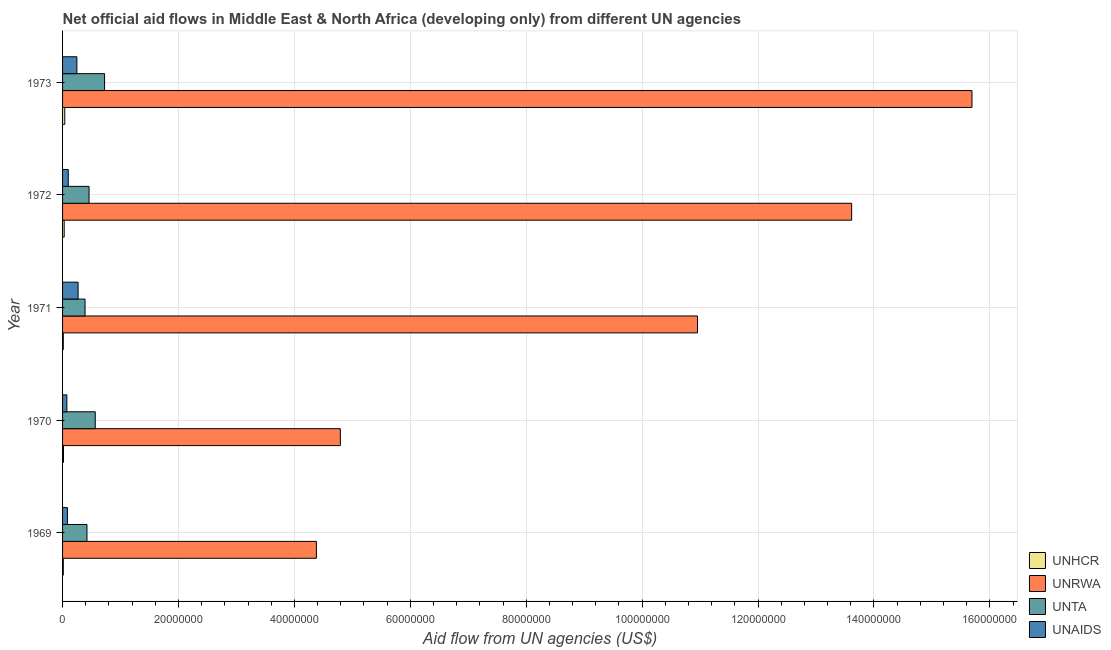How many different coloured bars are there?
Provide a succinct answer. 4. How many groups of bars are there?
Make the answer very short. 5. Are the number of bars per tick equal to the number of legend labels?
Your answer should be very brief. Yes. Are the number of bars on each tick of the Y-axis equal?
Provide a short and direct response. Yes. What is the label of the 2nd group of bars from the top?
Make the answer very short. 1972. What is the amount of aid given by unrwa in 1971?
Keep it short and to the point. 1.10e+08. Across all years, what is the maximum amount of aid given by unhcr?
Offer a terse response. 3.80e+05. Across all years, what is the minimum amount of aid given by unta?
Offer a very short reply. 3.88e+06. In which year was the amount of aid given by unaids maximum?
Ensure brevity in your answer.  1971. In which year was the amount of aid given by unaids minimum?
Give a very brief answer. 1970. What is the total amount of aid given by unrwa in the graph?
Provide a short and direct response. 4.94e+08. What is the difference between the amount of aid given by unta in 1969 and that in 1972?
Offer a terse response. -3.60e+05. What is the difference between the amount of aid given by unta in 1970 and the amount of aid given by unhcr in 1971?
Give a very brief answer. 5.51e+06. What is the average amount of aid given by unaids per year?
Offer a terse response. 1.54e+06. In the year 1973, what is the difference between the amount of aid given by unta and amount of aid given by unaids?
Provide a succinct answer. 4.78e+06. What is the ratio of the amount of aid given by unta in 1969 to that in 1971?
Provide a succinct answer. 1.08. Is the amount of aid given by unta in 1969 less than that in 1971?
Your answer should be very brief. No. Is the difference between the amount of aid given by unaids in 1972 and 1973 greater than the difference between the amount of aid given by unhcr in 1972 and 1973?
Offer a very short reply. No. What is the difference between the highest and the lowest amount of aid given by unaids?
Your response must be concise. 1.94e+06. In how many years, is the amount of aid given by unrwa greater than the average amount of aid given by unrwa taken over all years?
Keep it short and to the point. 3. Is the sum of the amount of aid given by unaids in 1970 and 1973 greater than the maximum amount of aid given by unhcr across all years?
Your response must be concise. Yes. Is it the case that in every year, the sum of the amount of aid given by unta and amount of aid given by unhcr is greater than the sum of amount of aid given by unaids and amount of aid given by unrwa?
Offer a terse response. Yes. What does the 2nd bar from the top in 1972 represents?
Provide a short and direct response. UNTA. What does the 4th bar from the bottom in 1973 represents?
Provide a short and direct response. UNAIDS. Is it the case that in every year, the sum of the amount of aid given by unhcr and amount of aid given by unrwa is greater than the amount of aid given by unta?
Provide a succinct answer. Yes. Are all the bars in the graph horizontal?
Make the answer very short. Yes. What is the difference between two consecutive major ticks on the X-axis?
Your answer should be very brief. 2.00e+07. Does the graph contain any zero values?
Offer a terse response. No. Does the graph contain grids?
Offer a terse response. Yes. How many legend labels are there?
Your answer should be compact. 4. What is the title of the graph?
Give a very brief answer. Net official aid flows in Middle East & North Africa (developing only) from different UN agencies. What is the label or title of the X-axis?
Ensure brevity in your answer.  Aid flow from UN agencies (US$). What is the Aid flow from UN agencies (US$) of UNRWA in 1969?
Your response must be concise. 4.38e+07. What is the Aid flow from UN agencies (US$) of UNTA in 1969?
Provide a succinct answer. 4.21e+06. What is the Aid flow from UN agencies (US$) of UNAIDS in 1969?
Provide a succinct answer. 8.40e+05. What is the Aid flow from UN agencies (US$) in UNRWA in 1970?
Provide a succinct answer. 4.79e+07. What is the Aid flow from UN agencies (US$) of UNTA in 1970?
Offer a very short reply. 5.64e+06. What is the Aid flow from UN agencies (US$) of UNAIDS in 1970?
Give a very brief answer. 7.40e+05. What is the Aid flow from UN agencies (US$) of UNHCR in 1971?
Your answer should be very brief. 1.30e+05. What is the Aid flow from UN agencies (US$) in UNRWA in 1971?
Make the answer very short. 1.10e+08. What is the Aid flow from UN agencies (US$) in UNTA in 1971?
Give a very brief answer. 3.88e+06. What is the Aid flow from UN agencies (US$) of UNAIDS in 1971?
Your answer should be compact. 2.68e+06. What is the Aid flow from UN agencies (US$) in UNRWA in 1972?
Your response must be concise. 1.36e+08. What is the Aid flow from UN agencies (US$) in UNTA in 1972?
Offer a very short reply. 4.57e+06. What is the Aid flow from UN agencies (US$) of UNAIDS in 1972?
Your answer should be very brief. 9.80e+05. What is the Aid flow from UN agencies (US$) in UNHCR in 1973?
Make the answer very short. 3.80e+05. What is the Aid flow from UN agencies (US$) in UNRWA in 1973?
Keep it short and to the point. 1.57e+08. What is the Aid flow from UN agencies (US$) of UNTA in 1973?
Ensure brevity in your answer.  7.25e+06. What is the Aid flow from UN agencies (US$) in UNAIDS in 1973?
Offer a very short reply. 2.47e+06. Across all years, what is the maximum Aid flow from UN agencies (US$) in UNHCR?
Your answer should be compact. 3.80e+05. Across all years, what is the maximum Aid flow from UN agencies (US$) of UNRWA?
Your answer should be very brief. 1.57e+08. Across all years, what is the maximum Aid flow from UN agencies (US$) in UNTA?
Ensure brevity in your answer.  7.25e+06. Across all years, what is the maximum Aid flow from UN agencies (US$) of UNAIDS?
Provide a succinct answer. 2.68e+06. Across all years, what is the minimum Aid flow from UN agencies (US$) of UNHCR?
Make the answer very short. 1.30e+05. Across all years, what is the minimum Aid flow from UN agencies (US$) in UNRWA?
Provide a short and direct response. 4.38e+07. Across all years, what is the minimum Aid flow from UN agencies (US$) of UNTA?
Make the answer very short. 3.88e+06. Across all years, what is the minimum Aid flow from UN agencies (US$) in UNAIDS?
Your answer should be compact. 7.40e+05. What is the total Aid flow from UN agencies (US$) of UNHCR in the graph?
Provide a succinct answer. 1.08e+06. What is the total Aid flow from UN agencies (US$) in UNRWA in the graph?
Keep it short and to the point. 4.94e+08. What is the total Aid flow from UN agencies (US$) of UNTA in the graph?
Offer a very short reply. 2.56e+07. What is the total Aid flow from UN agencies (US$) of UNAIDS in the graph?
Your response must be concise. 7.71e+06. What is the difference between the Aid flow from UN agencies (US$) in UNRWA in 1969 and that in 1970?
Your answer should be very brief. -4.13e+06. What is the difference between the Aid flow from UN agencies (US$) of UNTA in 1969 and that in 1970?
Your answer should be compact. -1.43e+06. What is the difference between the Aid flow from UN agencies (US$) of UNAIDS in 1969 and that in 1970?
Keep it short and to the point. 1.00e+05. What is the difference between the Aid flow from UN agencies (US$) in UNRWA in 1969 and that in 1971?
Your answer should be very brief. -6.58e+07. What is the difference between the Aid flow from UN agencies (US$) of UNAIDS in 1969 and that in 1971?
Ensure brevity in your answer.  -1.84e+06. What is the difference between the Aid flow from UN agencies (US$) of UNRWA in 1969 and that in 1972?
Your answer should be very brief. -9.24e+07. What is the difference between the Aid flow from UN agencies (US$) in UNTA in 1969 and that in 1972?
Offer a very short reply. -3.60e+05. What is the difference between the Aid flow from UN agencies (US$) in UNRWA in 1969 and that in 1973?
Offer a very short reply. -1.13e+08. What is the difference between the Aid flow from UN agencies (US$) in UNTA in 1969 and that in 1973?
Ensure brevity in your answer.  -3.04e+06. What is the difference between the Aid flow from UN agencies (US$) of UNAIDS in 1969 and that in 1973?
Give a very brief answer. -1.63e+06. What is the difference between the Aid flow from UN agencies (US$) in UNRWA in 1970 and that in 1971?
Offer a terse response. -6.16e+07. What is the difference between the Aid flow from UN agencies (US$) of UNTA in 1970 and that in 1971?
Offer a very short reply. 1.76e+06. What is the difference between the Aid flow from UN agencies (US$) of UNAIDS in 1970 and that in 1971?
Your answer should be compact. -1.94e+06. What is the difference between the Aid flow from UN agencies (US$) in UNRWA in 1970 and that in 1972?
Provide a succinct answer. -8.82e+07. What is the difference between the Aid flow from UN agencies (US$) of UNTA in 1970 and that in 1972?
Your answer should be compact. 1.07e+06. What is the difference between the Aid flow from UN agencies (US$) of UNHCR in 1970 and that in 1973?
Make the answer very short. -2.20e+05. What is the difference between the Aid flow from UN agencies (US$) in UNRWA in 1970 and that in 1973?
Provide a short and direct response. -1.09e+08. What is the difference between the Aid flow from UN agencies (US$) in UNTA in 1970 and that in 1973?
Your response must be concise. -1.61e+06. What is the difference between the Aid flow from UN agencies (US$) of UNAIDS in 1970 and that in 1973?
Make the answer very short. -1.73e+06. What is the difference between the Aid flow from UN agencies (US$) in UNHCR in 1971 and that in 1972?
Your answer should be very brief. -1.50e+05. What is the difference between the Aid flow from UN agencies (US$) of UNRWA in 1971 and that in 1972?
Offer a terse response. -2.66e+07. What is the difference between the Aid flow from UN agencies (US$) in UNTA in 1971 and that in 1972?
Ensure brevity in your answer.  -6.90e+05. What is the difference between the Aid flow from UN agencies (US$) in UNAIDS in 1971 and that in 1972?
Your answer should be compact. 1.70e+06. What is the difference between the Aid flow from UN agencies (US$) in UNRWA in 1971 and that in 1973?
Keep it short and to the point. -4.74e+07. What is the difference between the Aid flow from UN agencies (US$) in UNTA in 1971 and that in 1973?
Provide a short and direct response. -3.37e+06. What is the difference between the Aid flow from UN agencies (US$) of UNRWA in 1972 and that in 1973?
Offer a very short reply. -2.08e+07. What is the difference between the Aid flow from UN agencies (US$) in UNTA in 1972 and that in 1973?
Offer a terse response. -2.68e+06. What is the difference between the Aid flow from UN agencies (US$) of UNAIDS in 1972 and that in 1973?
Ensure brevity in your answer.  -1.49e+06. What is the difference between the Aid flow from UN agencies (US$) in UNHCR in 1969 and the Aid flow from UN agencies (US$) in UNRWA in 1970?
Make the answer very short. -4.78e+07. What is the difference between the Aid flow from UN agencies (US$) in UNHCR in 1969 and the Aid flow from UN agencies (US$) in UNTA in 1970?
Your answer should be very brief. -5.51e+06. What is the difference between the Aid flow from UN agencies (US$) in UNHCR in 1969 and the Aid flow from UN agencies (US$) in UNAIDS in 1970?
Your answer should be very brief. -6.10e+05. What is the difference between the Aid flow from UN agencies (US$) of UNRWA in 1969 and the Aid flow from UN agencies (US$) of UNTA in 1970?
Keep it short and to the point. 3.82e+07. What is the difference between the Aid flow from UN agencies (US$) of UNRWA in 1969 and the Aid flow from UN agencies (US$) of UNAIDS in 1970?
Make the answer very short. 4.31e+07. What is the difference between the Aid flow from UN agencies (US$) of UNTA in 1969 and the Aid flow from UN agencies (US$) of UNAIDS in 1970?
Make the answer very short. 3.47e+06. What is the difference between the Aid flow from UN agencies (US$) in UNHCR in 1969 and the Aid flow from UN agencies (US$) in UNRWA in 1971?
Provide a short and direct response. -1.09e+08. What is the difference between the Aid flow from UN agencies (US$) in UNHCR in 1969 and the Aid flow from UN agencies (US$) in UNTA in 1971?
Provide a short and direct response. -3.75e+06. What is the difference between the Aid flow from UN agencies (US$) in UNHCR in 1969 and the Aid flow from UN agencies (US$) in UNAIDS in 1971?
Ensure brevity in your answer.  -2.55e+06. What is the difference between the Aid flow from UN agencies (US$) in UNRWA in 1969 and the Aid flow from UN agencies (US$) in UNTA in 1971?
Offer a very short reply. 3.99e+07. What is the difference between the Aid flow from UN agencies (US$) of UNRWA in 1969 and the Aid flow from UN agencies (US$) of UNAIDS in 1971?
Provide a succinct answer. 4.11e+07. What is the difference between the Aid flow from UN agencies (US$) of UNTA in 1969 and the Aid flow from UN agencies (US$) of UNAIDS in 1971?
Your answer should be very brief. 1.53e+06. What is the difference between the Aid flow from UN agencies (US$) in UNHCR in 1969 and the Aid flow from UN agencies (US$) in UNRWA in 1972?
Offer a terse response. -1.36e+08. What is the difference between the Aid flow from UN agencies (US$) in UNHCR in 1969 and the Aid flow from UN agencies (US$) in UNTA in 1972?
Provide a succinct answer. -4.44e+06. What is the difference between the Aid flow from UN agencies (US$) in UNHCR in 1969 and the Aid flow from UN agencies (US$) in UNAIDS in 1972?
Keep it short and to the point. -8.50e+05. What is the difference between the Aid flow from UN agencies (US$) in UNRWA in 1969 and the Aid flow from UN agencies (US$) in UNTA in 1972?
Make the answer very short. 3.92e+07. What is the difference between the Aid flow from UN agencies (US$) in UNRWA in 1969 and the Aid flow from UN agencies (US$) in UNAIDS in 1972?
Make the answer very short. 4.28e+07. What is the difference between the Aid flow from UN agencies (US$) of UNTA in 1969 and the Aid flow from UN agencies (US$) of UNAIDS in 1972?
Make the answer very short. 3.23e+06. What is the difference between the Aid flow from UN agencies (US$) of UNHCR in 1969 and the Aid flow from UN agencies (US$) of UNRWA in 1973?
Your answer should be very brief. -1.57e+08. What is the difference between the Aid flow from UN agencies (US$) in UNHCR in 1969 and the Aid flow from UN agencies (US$) in UNTA in 1973?
Your response must be concise. -7.12e+06. What is the difference between the Aid flow from UN agencies (US$) in UNHCR in 1969 and the Aid flow from UN agencies (US$) in UNAIDS in 1973?
Provide a short and direct response. -2.34e+06. What is the difference between the Aid flow from UN agencies (US$) in UNRWA in 1969 and the Aid flow from UN agencies (US$) in UNTA in 1973?
Give a very brief answer. 3.66e+07. What is the difference between the Aid flow from UN agencies (US$) in UNRWA in 1969 and the Aid flow from UN agencies (US$) in UNAIDS in 1973?
Keep it short and to the point. 4.13e+07. What is the difference between the Aid flow from UN agencies (US$) in UNTA in 1969 and the Aid flow from UN agencies (US$) in UNAIDS in 1973?
Make the answer very short. 1.74e+06. What is the difference between the Aid flow from UN agencies (US$) of UNHCR in 1970 and the Aid flow from UN agencies (US$) of UNRWA in 1971?
Give a very brief answer. -1.09e+08. What is the difference between the Aid flow from UN agencies (US$) in UNHCR in 1970 and the Aid flow from UN agencies (US$) in UNTA in 1971?
Your answer should be compact. -3.72e+06. What is the difference between the Aid flow from UN agencies (US$) of UNHCR in 1970 and the Aid flow from UN agencies (US$) of UNAIDS in 1971?
Your answer should be compact. -2.52e+06. What is the difference between the Aid flow from UN agencies (US$) in UNRWA in 1970 and the Aid flow from UN agencies (US$) in UNTA in 1971?
Your answer should be compact. 4.40e+07. What is the difference between the Aid flow from UN agencies (US$) in UNRWA in 1970 and the Aid flow from UN agencies (US$) in UNAIDS in 1971?
Offer a very short reply. 4.52e+07. What is the difference between the Aid flow from UN agencies (US$) of UNTA in 1970 and the Aid flow from UN agencies (US$) of UNAIDS in 1971?
Your answer should be compact. 2.96e+06. What is the difference between the Aid flow from UN agencies (US$) of UNHCR in 1970 and the Aid flow from UN agencies (US$) of UNRWA in 1972?
Offer a very short reply. -1.36e+08. What is the difference between the Aid flow from UN agencies (US$) in UNHCR in 1970 and the Aid flow from UN agencies (US$) in UNTA in 1972?
Provide a short and direct response. -4.41e+06. What is the difference between the Aid flow from UN agencies (US$) in UNHCR in 1970 and the Aid flow from UN agencies (US$) in UNAIDS in 1972?
Give a very brief answer. -8.20e+05. What is the difference between the Aid flow from UN agencies (US$) of UNRWA in 1970 and the Aid flow from UN agencies (US$) of UNTA in 1972?
Ensure brevity in your answer.  4.34e+07. What is the difference between the Aid flow from UN agencies (US$) in UNRWA in 1970 and the Aid flow from UN agencies (US$) in UNAIDS in 1972?
Your answer should be very brief. 4.70e+07. What is the difference between the Aid flow from UN agencies (US$) in UNTA in 1970 and the Aid flow from UN agencies (US$) in UNAIDS in 1972?
Your response must be concise. 4.66e+06. What is the difference between the Aid flow from UN agencies (US$) of UNHCR in 1970 and the Aid flow from UN agencies (US$) of UNRWA in 1973?
Your answer should be very brief. -1.57e+08. What is the difference between the Aid flow from UN agencies (US$) of UNHCR in 1970 and the Aid flow from UN agencies (US$) of UNTA in 1973?
Ensure brevity in your answer.  -7.09e+06. What is the difference between the Aid flow from UN agencies (US$) in UNHCR in 1970 and the Aid flow from UN agencies (US$) in UNAIDS in 1973?
Offer a very short reply. -2.31e+06. What is the difference between the Aid flow from UN agencies (US$) in UNRWA in 1970 and the Aid flow from UN agencies (US$) in UNTA in 1973?
Offer a very short reply. 4.07e+07. What is the difference between the Aid flow from UN agencies (US$) of UNRWA in 1970 and the Aid flow from UN agencies (US$) of UNAIDS in 1973?
Ensure brevity in your answer.  4.55e+07. What is the difference between the Aid flow from UN agencies (US$) of UNTA in 1970 and the Aid flow from UN agencies (US$) of UNAIDS in 1973?
Provide a short and direct response. 3.17e+06. What is the difference between the Aid flow from UN agencies (US$) in UNHCR in 1971 and the Aid flow from UN agencies (US$) in UNRWA in 1972?
Offer a very short reply. -1.36e+08. What is the difference between the Aid flow from UN agencies (US$) of UNHCR in 1971 and the Aid flow from UN agencies (US$) of UNTA in 1972?
Give a very brief answer. -4.44e+06. What is the difference between the Aid flow from UN agencies (US$) in UNHCR in 1971 and the Aid flow from UN agencies (US$) in UNAIDS in 1972?
Your response must be concise. -8.50e+05. What is the difference between the Aid flow from UN agencies (US$) of UNRWA in 1971 and the Aid flow from UN agencies (US$) of UNTA in 1972?
Your answer should be very brief. 1.05e+08. What is the difference between the Aid flow from UN agencies (US$) in UNRWA in 1971 and the Aid flow from UN agencies (US$) in UNAIDS in 1972?
Your answer should be compact. 1.09e+08. What is the difference between the Aid flow from UN agencies (US$) of UNTA in 1971 and the Aid flow from UN agencies (US$) of UNAIDS in 1972?
Make the answer very short. 2.90e+06. What is the difference between the Aid flow from UN agencies (US$) in UNHCR in 1971 and the Aid flow from UN agencies (US$) in UNRWA in 1973?
Keep it short and to the point. -1.57e+08. What is the difference between the Aid flow from UN agencies (US$) of UNHCR in 1971 and the Aid flow from UN agencies (US$) of UNTA in 1973?
Ensure brevity in your answer.  -7.12e+06. What is the difference between the Aid flow from UN agencies (US$) of UNHCR in 1971 and the Aid flow from UN agencies (US$) of UNAIDS in 1973?
Your answer should be compact. -2.34e+06. What is the difference between the Aid flow from UN agencies (US$) in UNRWA in 1971 and the Aid flow from UN agencies (US$) in UNTA in 1973?
Provide a short and direct response. 1.02e+08. What is the difference between the Aid flow from UN agencies (US$) of UNRWA in 1971 and the Aid flow from UN agencies (US$) of UNAIDS in 1973?
Keep it short and to the point. 1.07e+08. What is the difference between the Aid flow from UN agencies (US$) in UNTA in 1971 and the Aid flow from UN agencies (US$) in UNAIDS in 1973?
Offer a very short reply. 1.41e+06. What is the difference between the Aid flow from UN agencies (US$) of UNHCR in 1972 and the Aid flow from UN agencies (US$) of UNRWA in 1973?
Your answer should be very brief. -1.57e+08. What is the difference between the Aid flow from UN agencies (US$) of UNHCR in 1972 and the Aid flow from UN agencies (US$) of UNTA in 1973?
Your answer should be compact. -6.97e+06. What is the difference between the Aid flow from UN agencies (US$) in UNHCR in 1972 and the Aid flow from UN agencies (US$) in UNAIDS in 1973?
Your answer should be very brief. -2.19e+06. What is the difference between the Aid flow from UN agencies (US$) in UNRWA in 1972 and the Aid flow from UN agencies (US$) in UNTA in 1973?
Make the answer very short. 1.29e+08. What is the difference between the Aid flow from UN agencies (US$) of UNRWA in 1972 and the Aid flow from UN agencies (US$) of UNAIDS in 1973?
Your answer should be very brief. 1.34e+08. What is the difference between the Aid flow from UN agencies (US$) in UNTA in 1972 and the Aid flow from UN agencies (US$) in UNAIDS in 1973?
Provide a short and direct response. 2.10e+06. What is the average Aid flow from UN agencies (US$) of UNHCR per year?
Ensure brevity in your answer.  2.16e+05. What is the average Aid flow from UN agencies (US$) in UNRWA per year?
Provide a short and direct response. 9.89e+07. What is the average Aid flow from UN agencies (US$) of UNTA per year?
Your answer should be very brief. 5.11e+06. What is the average Aid flow from UN agencies (US$) of UNAIDS per year?
Provide a succinct answer. 1.54e+06. In the year 1969, what is the difference between the Aid flow from UN agencies (US$) in UNHCR and Aid flow from UN agencies (US$) in UNRWA?
Your response must be concise. -4.37e+07. In the year 1969, what is the difference between the Aid flow from UN agencies (US$) of UNHCR and Aid flow from UN agencies (US$) of UNTA?
Offer a very short reply. -4.08e+06. In the year 1969, what is the difference between the Aid flow from UN agencies (US$) of UNHCR and Aid flow from UN agencies (US$) of UNAIDS?
Your answer should be very brief. -7.10e+05. In the year 1969, what is the difference between the Aid flow from UN agencies (US$) of UNRWA and Aid flow from UN agencies (US$) of UNTA?
Keep it short and to the point. 3.96e+07. In the year 1969, what is the difference between the Aid flow from UN agencies (US$) of UNRWA and Aid flow from UN agencies (US$) of UNAIDS?
Keep it short and to the point. 4.30e+07. In the year 1969, what is the difference between the Aid flow from UN agencies (US$) in UNTA and Aid flow from UN agencies (US$) in UNAIDS?
Provide a short and direct response. 3.37e+06. In the year 1970, what is the difference between the Aid flow from UN agencies (US$) in UNHCR and Aid flow from UN agencies (US$) in UNRWA?
Ensure brevity in your answer.  -4.78e+07. In the year 1970, what is the difference between the Aid flow from UN agencies (US$) of UNHCR and Aid flow from UN agencies (US$) of UNTA?
Make the answer very short. -5.48e+06. In the year 1970, what is the difference between the Aid flow from UN agencies (US$) in UNHCR and Aid flow from UN agencies (US$) in UNAIDS?
Ensure brevity in your answer.  -5.80e+05. In the year 1970, what is the difference between the Aid flow from UN agencies (US$) of UNRWA and Aid flow from UN agencies (US$) of UNTA?
Your answer should be very brief. 4.23e+07. In the year 1970, what is the difference between the Aid flow from UN agencies (US$) in UNRWA and Aid flow from UN agencies (US$) in UNAIDS?
Provide a succinct answer. 4.72e+07. In the year 1970, what is the difference between the Aid flow from UN agencies (US$) in UNTA and Aid flow from UN agencies (US$) in UNAIDS?
Give a very brief answer. 4.90e+06. In the year 1971, what is the difference between the Aid flow from UN agencies (US$) in UNHCR and Aid flow from UN agencies (US$) in UNRWA?
Offer a terse response. -1.09e+08. In the year 1971, what is the difference between the Aid flow from UN agencies (US$) of UNHCR and Aid flow from UN agencies (US$) of UNTA?
Provide a succinct answer. -3.75e+06. In the year 1971, what is the difference between the Aid flow from UN agencies (US$) in UNHCR and Aid flow from UN agencies (US$) in UNAIDS?
Provide a short and direct response. -2.55e+06. In the year 1971, what is the difference between the Aid flow from UN agencies (US$) in UNRWA and Aid flow from UN agencies (US$) in UNTA?
Give a very brief answer. 1.06e+08. In the year 1971, what is the difference between the Aid flow from UN agencies (US$) in UNRWA and Aid flow from UN agencies (US$) in UNAIDS?
Ensure brevity in your answer.  1.07e+08. In the year 1971, what is the difference between the Aid flow from UN agencies (US$) of UNTA and Aid flow from UN agencies (US$) of UNAIDS?
Your response must be concise. 1.20e+06. In the year 1972, what is the difference between the Aid flow from UN agencies (US$) in UNHCR and Aid flow from UN agencies (US$) in UNRWA?
Your answer should be compact. -1.36e+08. In the year 1972, what is the difference between the Aid flow from UN agencies (US$) of UNHCR and Aid flow from UN agencies (US$) of UNTA?
Offer a terse response. -4.29e+06. In the year 1972, what is the difference between the Aid flow from UN agencies (US$) of UNHCR and Aid flow from UN agencies (US$) of UNAIDS?
Give a very brief answer. -7.00e+05. In the year 1972, what is the difference between the Aid flow from UN agencies (US$) in UNRWA and Aid flow from UN agencies (US$) in UNTA?
Your response must be concise. 1.32e+08. In the year 1972, what is the difference between the Aid flow from UN agencies (US$) in UNRWA and Aid flow from UN agencies (US$) in UNAIDS?
Ensure brevity in your answer.  1.35e+08. In the year 1972, what is the difference between the Aid flow from UN agencies (US$) of UNTA and Aid flow from UN agencies (US$) of UNAIDS?
Keep it short and to the point. 3.59e+06. In the year 1973, what is the difference between the Aid flow from UN agencies (US$) of UNHCR and Aid flow from UN agencies (US$) of UNRWA?
Keep it short and to the point. -1.57e+08. In the year 1973, what is the difference between the Aid flow from UN agencies (US$) in UNHCR and Aid flow from UN agencies (US$) in UNTA?
Offer a terse response. -6.87e+06. In the year 1973, what is the difference between the Aid flow from UN agencies (US$) of UNHCR and Aid flow from UN agencies (US$) of UNAIDS?
Offer a very short reply. -2.09e+06. In the year 1973, what is the difference between the Aid flow from UN agencies (US$) of UNRWA and Aid flow from UN agencies (US$) of UNTA?
Keep it short and to the point. 1.50e+08. In the year 1973, what is the difference between the Aid flow from UN agencies (US$) in UNRWA and Aid flow from UN agencies (US$) in UNAIDS?
Your answer should be very brief. 1.54e+08. In the year 1973, what is the difference between the Aid flow from UN agencies (US$) in UNTA and Aid flow from UN agencies (US$) in UNAIDS?
Your response must be concise. 4.78e+06. What is the ratio of the Aid flow from UN agencies (US$) of UNHCR in 1969 to that in 1970?
Your answer should be very brief. 0.81. What is the ratio of the Aid flow from UN agencies (US$) in UNRWA in 1969 to that in 1970?
Keep it short and to the point. 0.91. What is the ratio of the Aid flow from UN agencies (US$) of UNTA in 1969 to that in 1970?
Your answer should be compact. 0.75. What is the ratio of the Aid flow from UN agencies (US$) in UNAIDS in 1969 to that in 1970?
Your answer should be very brief. 1.14. What is the ratio of the Aid flow from UN agencies (US$) in UNRWA in 1969 to that in 1971?
Your response must be concise. 0.4. What is the ratio of the Aid flow from UN agencies (US$) of UNTA in 1969 to that in 1971?
Offer a very short reply. 1.09. What is the ratio of the Aid flow from UN agencies (US$) of UNAIDS in 1969 to that in 1971?
Your response must be concise. 0.31. What is the ratio of the Aid flow from UN agencies (US$) in UNHCR in 1969 to that in 1972?
Provide a succinct answer. 0.46. What is the ratio of the Aid flow from UN agencies (US$) of UNRWA in 1969 to that in 1972?
Give a very brief answer. 0.32. What is the ratio of the Aid flow from UN agencies (US$) of UNTA in 1969 to that in 1972?
Offer a very short reply. 0.92. What is the ratio of the Aid flow from UN agencies (US$) in UNHCR in 1969 to that in 1973?
Your answer should be very brief. 0.34. What is the ratio of the Aid flow from UN agencies (US$) in UNRWA in 1969 to that in 1973?
Offer a terse response. 0.28. What is the ratio of the Aid flow from UN agencies (US$) of UNTA in 1969 to that in 1973?
Offer a very short reply. 0.58. What is the ratio of the Aid flow from UN agencies (US$) in UNAIDS in 1969 to that in 1973?
Offer a very short reply. 0.34. What is the ratio of the Aid flow from UN agencies (US$) in UNHCR in 1970 to that in 1971?
Offer a terse response. 1.23. What is the ratio of the Aid flow from UN agencies (US$) in UNRWA in 1970 to that in 1971?
Give a very brief answer. 0.44. What is the ratio of the Aid flow from UN agencies (US$) of UNTA in 1970 to that in 1971?
Offer a very short reply. 1.45. What is the ratio of the Aid flow from UN agencies (US$) in UNAIDS in 1970 to that in 1971?
Give a very brief answer. 0.28. What is the ratio of the Aid flow from UN agencies (US$) of UNHCR in 1970 to that in 1972?
Offer a terse response. 0.57. What is the ratio of the Aid flow from UN agencies (US$) in UNRWA in 1970 to that in 1972?
Make the answer very short. 0.35. What is the ratio of the Aid flow from UN agencies (US$) of UNTA in 1970 to that in 1972?
Provide a short and direct response. 1.23. What is the ratio of the Aid flow from UN agencies (US$) of UNAIDS in 1970 to that in 1972?
Offer a terse response. 0.76. What is the ratio of the Aid flow from UN agencies (US$) in UNHCR in 1970 to that in 1973?
Provide a succinct answer. 0.42. What is the ratio of the Aid flow from UN agencies (US$) of UNRWA in 1970 to that in 1973?
Offer a terse response. 0.31. What is the ratio of the Aid flow from UN agencies (US$) of UNTA in 1970 to that in 1973?
Your response must be concise. 0.78. What is the ratio of the Aid flow from UN agencies (US$) of UNAIDS in 1970 to that in 1973?
Your answer should be compact. 0.3. What is the ratio of the Aid flow from UN agencies (US$) of UNHCR in 1971 to that in 1972?
Offer a very short reply. 0.46. What is the ratio of the Aid flow from UN agencies (US$) in UNRWA in 1971 to that in 1972?
Offer a very short reply. 0.8. What is the ratio of the Aid flow from UN agencies (US$) in UNTA in 1971 to that in 1972?
Your response must be concise. 0.85. What is the ratio of the Aid flow from UN agencies (US$) of UNAIDS in 1971 to that in 1972?
Offer a terse response. 2.73. What is the ratio of the Aid flow from UN agencies (US$) in UNHCR in 1971 to that in 1973?
Ensure brevity in your answer.  0.34. What is the ratio of the Aid flow from UN agencies (US$) of UNRWA in 1971 to that in 1973?
Make the answer very short. 0.7. What is the ratio of the Aid flow from UN agencies (US$) of UNTA in 1971 to that in 1973?
Keep it short and to the point. 0.54. What is the ratio of the Aid flow from UN agencies (US$) in UNAIDS in 1971 to that in 1973?
Offer a terse response. 1.08. What is the ratio of the Aid flow from UN agencies (US$) in UNHCR in 1972 to that in 1973?
Give a very brief answer. 0.74. What is the ratio of the Aid flow from UN agencies (US$) in UNRWA in 1972 to that in 1973?
Offer a very short reply. 0.87. What is the ratio of the Aid flow from UN agencies (US$) of UNTA in 1972 to that in 1973?
Your answer should be compact. 0.63. What is the ratio of the Aid flow from UN agencies (US$) in UNAIDS in 1972 to that in 1973?
Provide a succinct answer. 0.4. What is the difference between the highest and the second highest Aid flow from UN agencies (US$) of UNRWA?
Provide a succinct answer. 2.08e+07. What is the difference between the highest and the second highest Aid flow from UN agencies (US$) of UNTA?
Make the answer very short. 1.61e+06. What is the difference between the highest and the second highest Aid flow from UN agencies (US$) in UNAIDS?
Offer a terse response. 2.10e+05. What is the difference between the highest and the lowest Aid flow from UN agencies (US$) of UNRWA?
Offer a very short reply. 1.13e+08. What is the difference between the highest and the lowest Aid flow from UN agencies (US$) of UNTA?
Provide a short and direct response. 3.37e+06. What is the difference between the highest and the lowest Aid flow from UN agencies (US$) of UNAIDS?
Provide a short and direct response. 1.94e+06. 